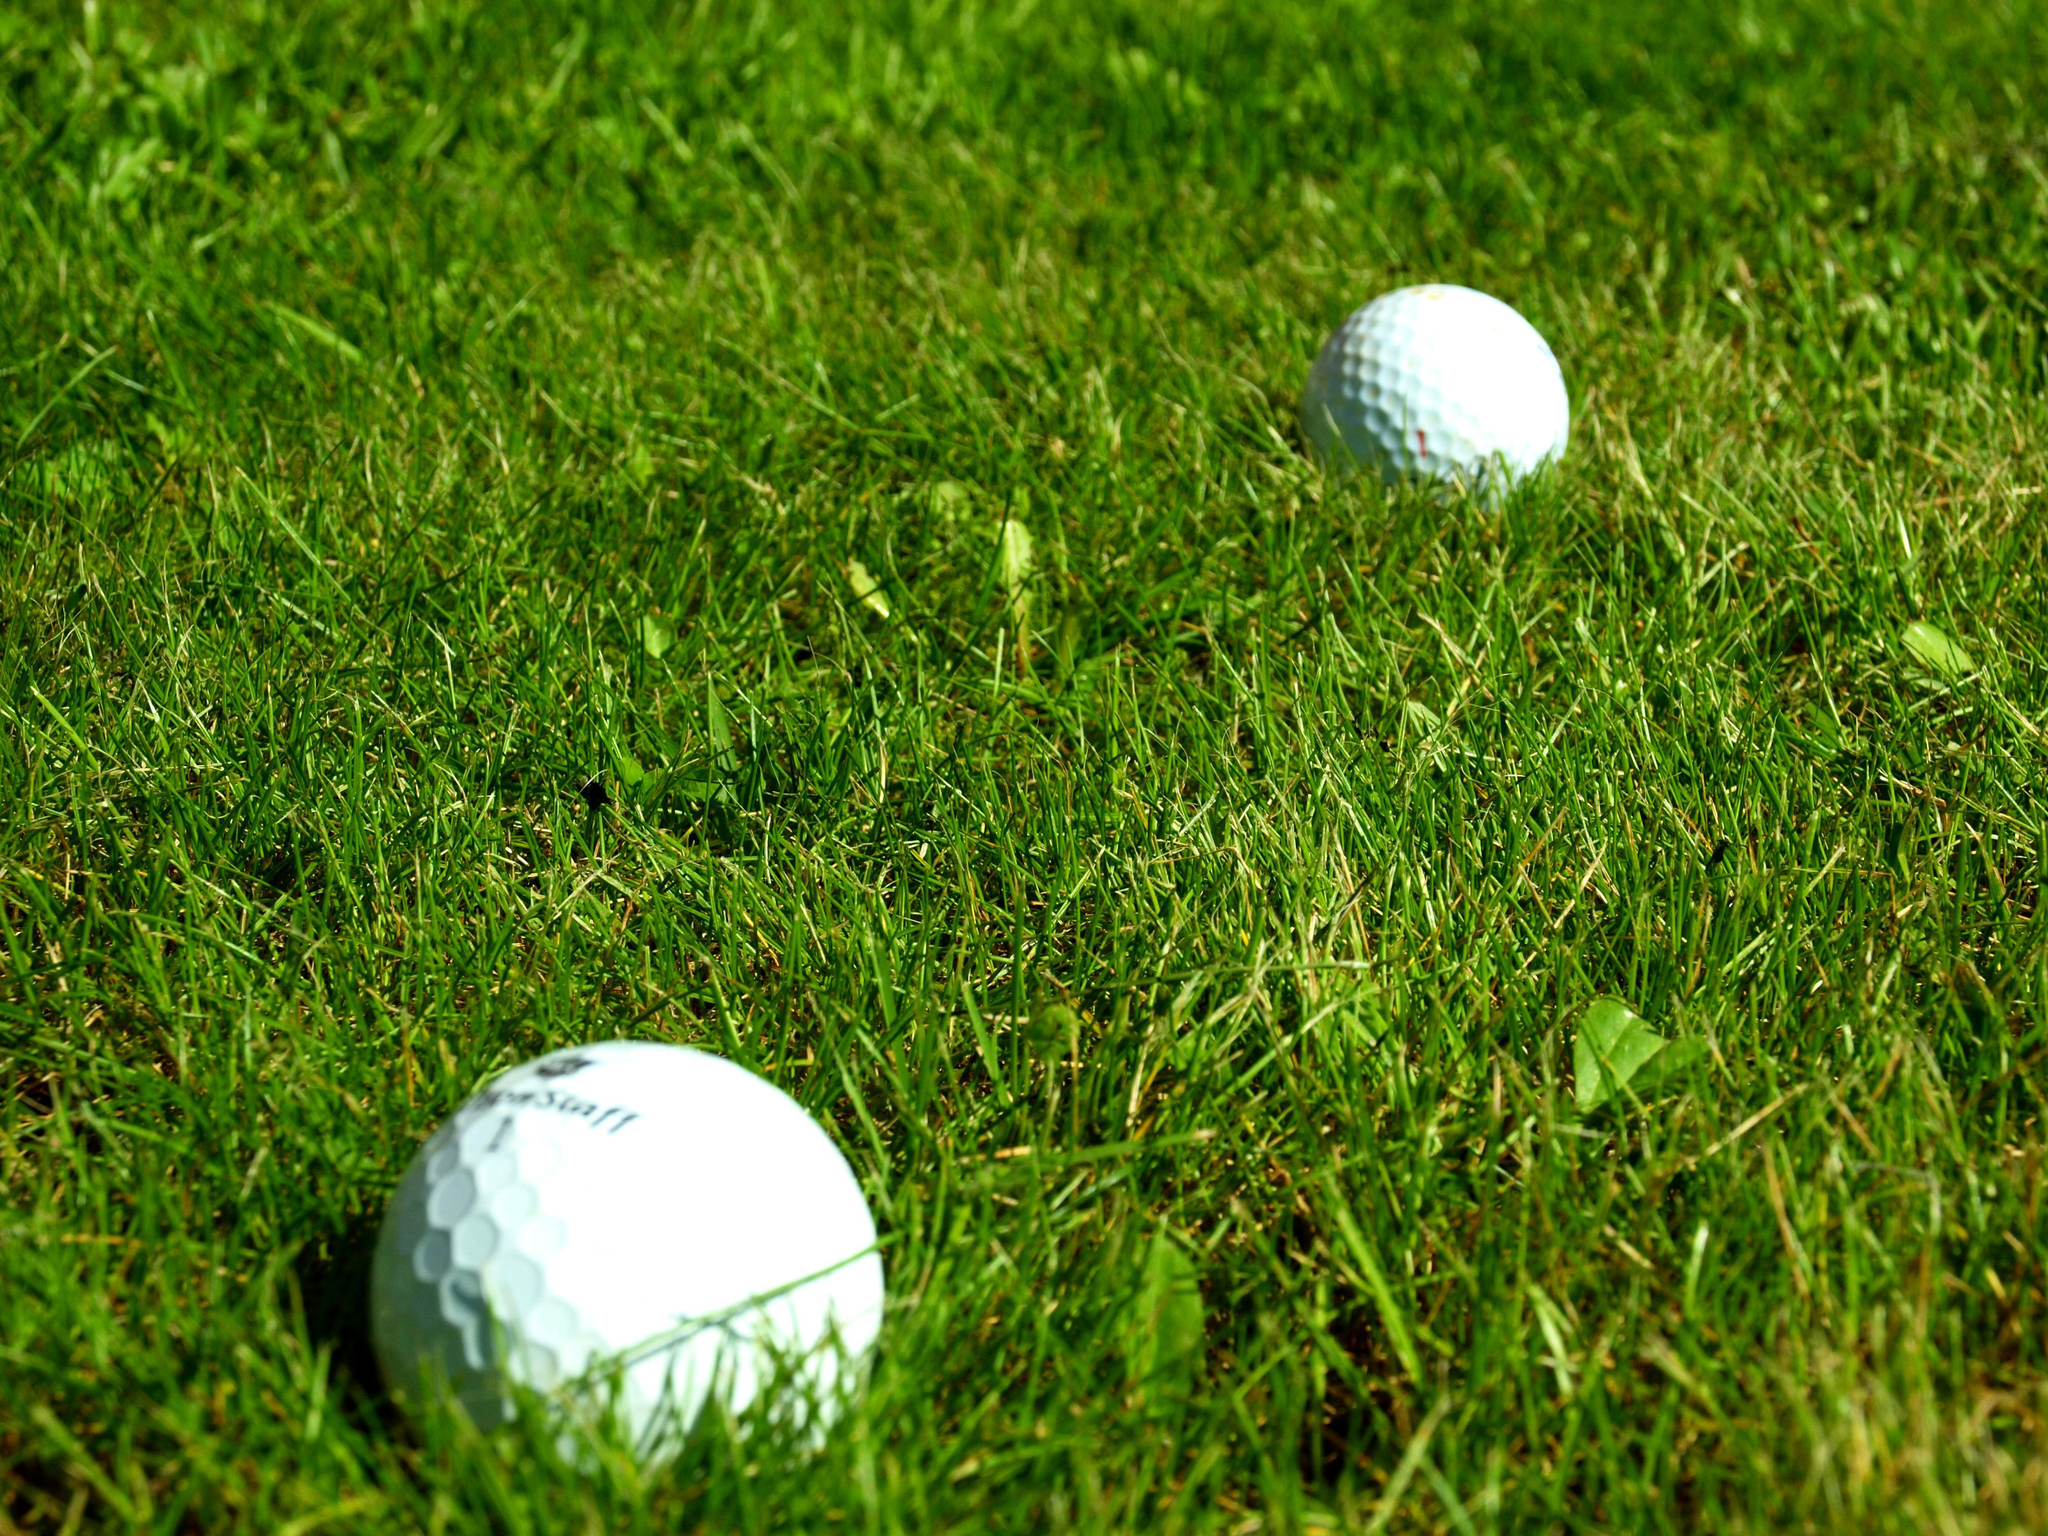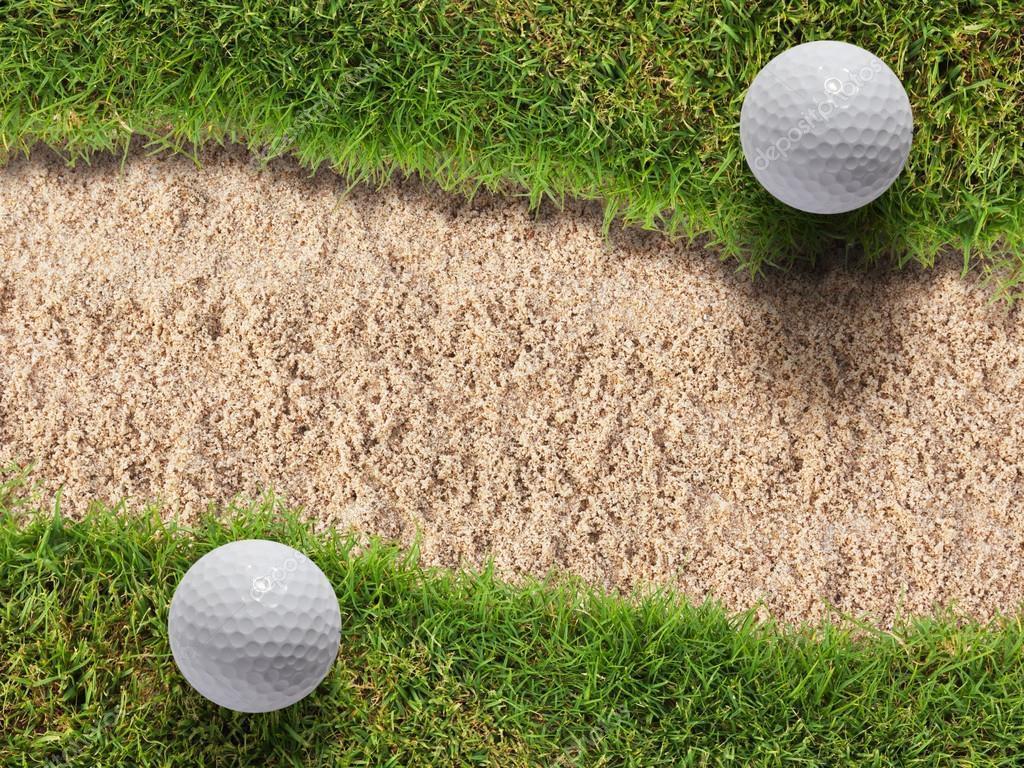The first image is the image on the left, the second image is the image on the right. For the images shown, is this caption "two balls are placed side by side in front of a dome type cover" true? Answer yes or no. No. 